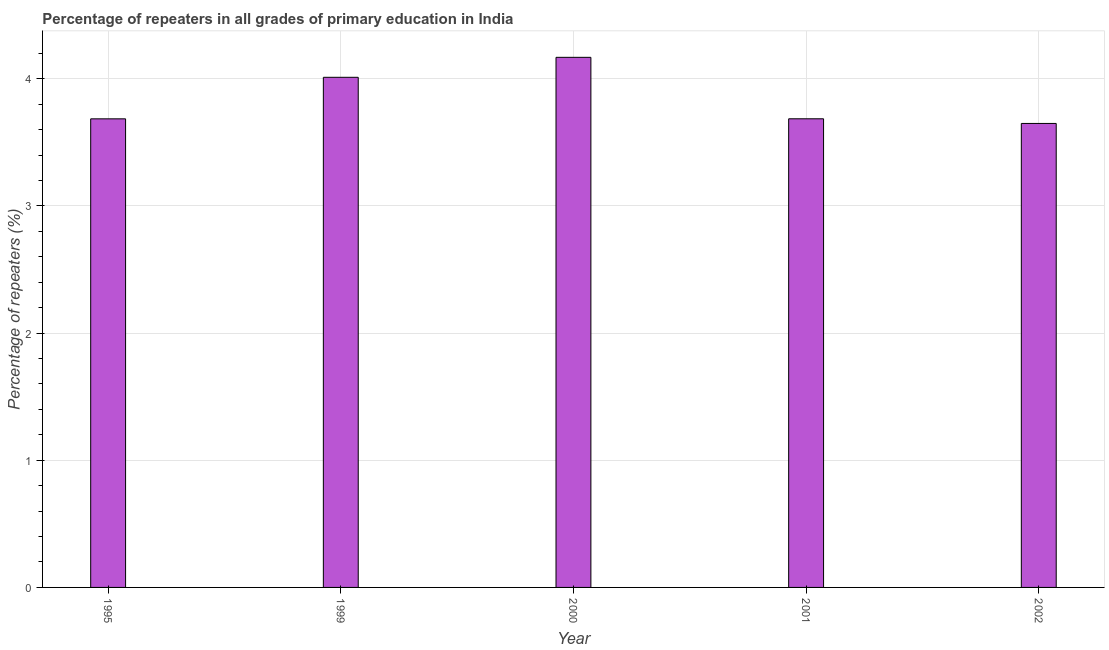Does the graph contain any zero values?
Your answer should be compact. No. Does the graph contain grids?
Keep it short and to the point. Yes. What is the title of the graph?
Offer a very short reply. Percentage of repeaters in all grades of primary education in India. What is the label or title of the X-axis?
Give a very brief answer. Year. What is the label or title of the Y-axis?
Your answer should be very brief. Percentage of repeaters (%). What is the percentage of repeaters in primary education in 2002?
Your answer should be compact. 3.65. Across all years, what is the maximum percentage of repeaters in primary education?
Give a very brief answer. 4.17. Across all years, what is the minimum percentage of repeaters in primary education?
Your answer should be very brief. 3.65. In which year was the percentage of repeaters in primary education minimum?
Offer a very short reply. 2002. What is the sum of the percentage of repeaters in primary education?
Offer a very short reply. 19.2. What is the difference between the percentage of repeaters in primary education in 2000 and 2001?
Make the answer very short. 0.48. What is the average percentage of repeaters in primary education per year?
Make the answer very short. 3.84. What is the median percentage of repeaters in primary education?
Your response must be concise. 3.69. Do a majority of the years between 2002 and 2000 (inclusive) have percentage of repeaters in primary education greater than 1.2 %?
Provide a succinct answer. Yes. What is the ratio of the percentage of repeaters in primary education in 1995 to that in 2001?
Your response must be concise. 1. Is the percentage of repeaters in primary education in 1999 less than that in 2001?
Provide a short and direct response. No. Is the difference between the percentage of repeaters in primary education in 1999 and 2000 greater than the difference between any two years?
Provide a short and direct response. No. What is the difference between the highest and the second highest percentage of repeaters in primary education?
Offer a terse response. 0.16. Is the sum of the percentage of repeaters in primary education in 1995 and 2000 greater than the maximum percentage of repeaters in primary education across all years?
Your answer should be compact. Yes. What is the difference between the highest and the lowest percentage of repeaters in primary education?
Give a very brief answer. 0.52. In how many years, is the percentage of repeaters in primary education greater than the average percentage of repeaters in primary education taken over all years?
Provide a short and direct response. 2. How many bars are there?
Provide a succinct answer. 5. What is the difference between two consecutive major ticks on the Y-axis?
Give a very brief answer. 1. What is the Percentage of repeaters (%) in 1995?
Provide a succinct answer. 3.69. What is the Percentage of repeaters (%) in 1999?
Your answer should be very brief. 4.01. What is the Percentage of repeaters (%) in 2000?
Make the answer very short. 4.17. What is the Percentage of repeaters (%) of 2001?
Ensure brevity in your answer.  3.69. What is the Percentage of repeaters (%) in 2002?
Provide a short and direct response. 3.65. What is the difference between the Percentage of repeaters (%) in 1995 and 1999?
Your response must be concise. -0.33. What is the difference between the Percentage of repeaters (%) in 1995 and 2000?
Your answer should be very brief. -0.48. What is the difference between the Percentage of repeaters (%) in 1995 and 2001?
Your answer should be compact. -0. What is the difference between the Percentage of repeaters (%) in 1995 and 2002?
Your answer should be compact. 0.04. What is the difference between the Percentage of repeaters (%) in 1999 and 2000?
Provide a short and direct response. -0.16. What is the difference between the Percentage of repeaters (%) in 1999 and 2001?
Provide a short and direct response. 0.33. What is the difference between the Percentage of repeaters (%) in 1999 and 2002?
Your answer should be very brief. 0.36. What is the difference between the Percentage of repeaters (%) in 2000 and 2001?
Provide a short and direct response. 0.48. What is the difference between the Percentage of repeaters (%) in 2000 and 2002?
Offer a terse response. 0.52. What is the difference between the Percentage of repeaters (%) in 2001 and 2002?
Your response must be concise. 0.04. What is the ratio of the Percentage of repeaters (%) in 1995 to that in 1999?
Offer a terse response. 0.92. What is the ratio of the Percentage of repeaters (%) in 1995 to that in 2000?
Ensure brevity in your answer.  0.88. What is the ratio of the Percentage of repeaters (%) in 1995 to that in 2001?
Offer a very short reply. 1. What is the ratio of the Percentage of repeaters (%) in 1995 to that in 2002?
Keep it short and to the point. 1.01. What is the ratio of the Percentage of repeaters (%) in 1999 to that in 2000?
Make the answer very short. 0.96. What is the ratio of the Percentage of repeaters (%) in 1999 to that in 2001?
Make the answer very short. 1.09. What is the ratio of the Percentage of repeaters (%) in 1999 to that in 2002?
Ensure brevity in your answer.  1.1. What is the ratio of the Percentage of repeaters (%) in 2000 to that in 2001?
Provide a succinct answer. 1.13. What is the ratio of the Percentage of repeaters (%) in 2000 to that in 2002?
Make the answer very short. 1.14. 